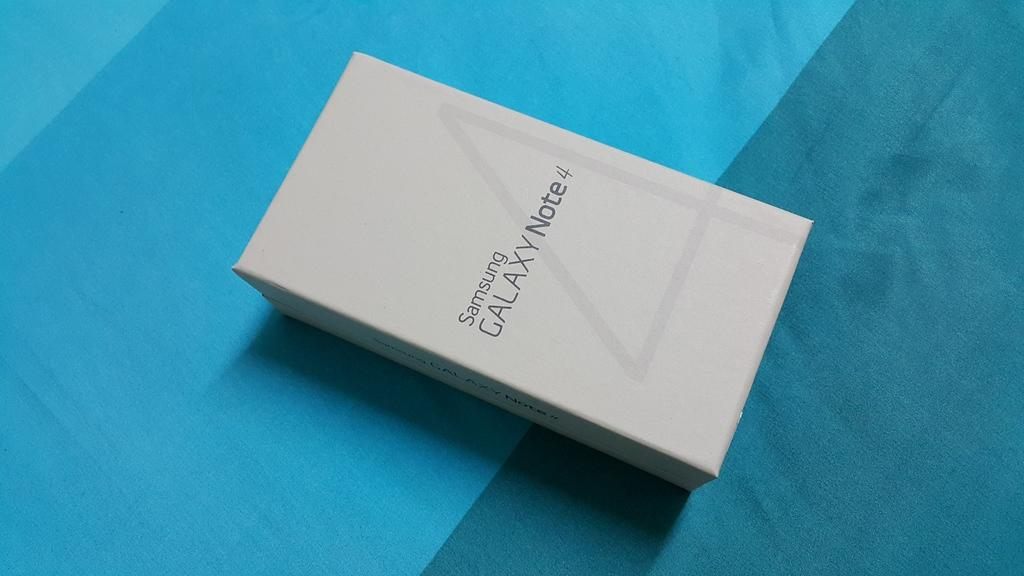<image>
Write a terse but informative summary of the picture. A box that contains a Samsung Galaxy Note 4. 